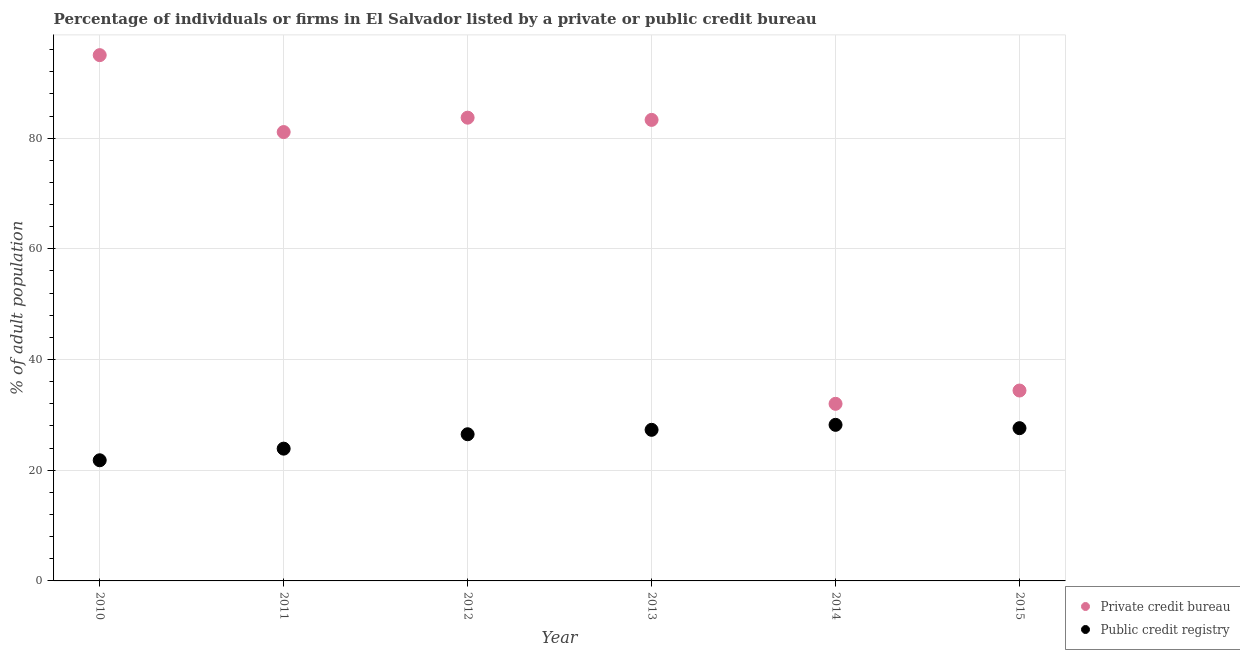How many different coloured dotlines are there?
Give a very brief answer. 2. What is the percentage of firms listed by private credit bureau in 2013?
Offer a terse response. 83.3. Across all years, what is the minimum percentage of firms listed by public credit bureau?
Provide a succinct answer. 21.8. In which year was the percentage of firms listed by private credit bureau maximum?
Your response must be concise. 2010. In which year was the percentage of firms listed by public credit bureau minimum?
Your response must be concise. 2010. What is the total percentage of firms listed by public credit bureau in the graph?
Offer a terse response. 155.3. What is the difference between the percentage of firms listed by public credit bureau in 2010 and that in 2015?
Provide a succinct answer. -5.8. What is the difference between the percentage of firms listed by public credit bureau in 2011 and the percentage of firms listed by private credit bureau in 2013?
Offer a very short reply. -59.4. What is the average percentage of firms listed by public credit bureau per year?
Provide a succinct answer. 25.88. In the year 2013, what is the difference between the percentage of firms listed by private credit bureau and percentage of firms listed by public credit bureau?
Offer a very short reply. 56. What is the ratio of the percentage of firms listed by private credit bureau in 2010 to that in 2013?
Offer a terse response. 1.14. Is the percentage of firms listed by public credit bureau in 2011 less than that in 2012?
Offer a very short reply. Yes. Is the difference between the percentage of firms listed by private credit bureau in 2012 and 2015 greater than the difference between the percentage of firms listed by public credit bureau in 2012 and 2015?
Your answer should be very brief. Yes. What is the difference between the highest and the second highest percentage of firms listed by public credit bureau?
Offer a very short reply. 0.6. What is the difference between the highest and the lowest percentage of firms listed by private credit bureau?
Ensure brevity in your answer.  63. In how many years, is the percentage of firms listed by public credit bureau greater than the average percentage of firms listed by public credit bureau taken over all years?
Your answer should be very brief. 4. Does the percentage of firms listed by private credit bureau monotonically increase over the years?
Provide a succinct answer. No. What is the difference between two consecutive major ticks on the Y-axis?
Your response must be concise. 20. Are the values on the major ticks of Y-axis written in scientific E-notation?
Offer a very short reply. No. Where does the legend appear in the graph?
Offer a very short reply. Bottom right. How many legend labels are there?
Offer a very short reply. 2. How are the legend labels stacked?
Provide a short and direct response. Vertical. What is the title of the graph?
Provide a short and direct response. Percentage of individuals or firms in El Salvador listed by a private or public credit bureau. Does "Food and tobacco" appear as one of the legend labels in the graph?
Keep it short and to the point. No. What is the label or title of the Y-axis?
Offer a very short reply. % of adult population. What is the % of adult population in Private credit bureau in 2010?
Offer a very short reply. 95. What is the % of adult population of Public credit registry in 2010?
Ensure brevity in your answer.  21.8. What is the % of adult population of Private credit bureau in 2011?
Your response must be concise. 81.1. What is the % of adult population of Public credit registry in 2011?
Offer a very short reply. 23.9. What is the % of adult population of Private credit bureau in 2012?
Keep it short and to the point. 83.7. What is the % of adult population of Private credit bureau in 2013?
Offer a very short reply. 83.3. What is the % of adult population of Public credit registry in 2013?
Offer a terse response. 27.3. What is the % of adult population in Private credit bureau in 2014?
Provide a short and direct response. 32. What is the % of adult population in Public credit registry in 2014?
Make the answer very short. 28.2. What is the % of adult population in Private credit bureau in 2015?
Give a very brief answer. 34.4. What is the % of adult population in Public credit registry in 2015?
Your answer should be very brief. 27.6. Across all years, what is the maximum % of adult population in Private credit bureau?
Keep it short and to the point. 95. Across all years, what is the maximum % of adult population in Public credit registry?
Your answer should be compact. 28.2. Across all years, what is the minimum % of adult population in Public credit registry?
Offer a very short reply. 21.8. What is the total % of adult population in Private credit bureau in the graph?
Offer a terse response. 409.5. What is the total % of adult population of Public credit registry in the graph?
Make the answer very short. 155.3. What is the difference between the % of adult population of Private credit bureau in 2010 and that in 2011?
Keep it short and to the point. 13.9. What is the difference between the % of adult population of Public credit registry in 2010 and that in 2011?
Ensure brevity in your answer.  -2.1. What is the difference between the % of adult population in Private credit bureau in 2010 and that in 2012?
Give a very brief answer. 11.3. What is the difference between the % of adult population of Private credit bureau in 2010 and that in 2014?
Ensure brevity in your answer.  63. What is the difference between the % of adult population of Private credit bureau in 2010 and that in 2015?
Your response must be concise. 60.6. What is the difference between the % of adult population of Private credit bureau in 2011 and that in 2012?
Give a very brief answer. -2.6. What is the difference between the % of adult population in Public credit registry in 2011 and that in 2012?
Your answer should be very brief. -2.6. What is the difference between the % of adult population of Private credit bureau in 2011 and that in 2013?
Your response must be concise. -2.2. What is the difference between the % of adult population of Public credit registry in 2011 and that in 2013?
Make the answer very short. -3.4. What is the difference between the % of adult population of Private credit bureau in 2011 and that in 2014?
Keep it short and to the point. 49.1. What is the difference between the % of adult population of Public credit registry in 2011 and that in 2014?
Ensure brevity in your answer.  -4.3. What is the difference between the % of adult population in Private credit bureau in 2011 and that in 2015?
Provide a succinct answer. 46.7. What is the difference between the % of adult population in Public credit registry in 2011 and that in 2015?
Ensure brevity in your answer.  -3.7. What is the difference between the % of adult population in Private credit bureau in 2012 and that in 2013?
Keep it short and to the point. 0.4. What is the difference between the % of adult population of Public credit registry in 2012 and that in 2013?
Keep it short and to the point. -0.8. What is the difference between the % of adult population in Private credit bureau in 2012 and that in 2014?
Provide a short and direct response. 51.7. What is the difference between the % of adult population in Public credit registry in 2012 and that in 2014?
Your answer should be compact. -1.7. What is the difference between the % of adult population of Private credit bureau in 2012 and that in 2015?
Your response must be concise. 49.3. What is the difference between the % of adult population in Private credit bureau in 2013 and that in 2014?
Offer a terse response. 51.3. What is the difference between the % of adult population of Public credit registry in 2013 and that in 2014?
Your response must be concise. -0.9. What is the difference between the % of adult population in Private credit bureau in 2013 and that in 2015?
Ensure brevity in your answer.  48.9. What is the difference between the % of adult population of Public credit registry in 2013 and that in 2015?
Give a very brief answer. -0.3. What is the difference between the % of adult population in Private credit bureau in 2010 and the % of adult population in Public credit registry in 2011?
Keep it short and to the point. 71.1. What is the difference between the % of adult population in Private credit bureau in 2010 and the % of adult population in Public credit registry in 2012?
Provide a short and direct response. 68.5. What is the difference between the % of adult population in Private credit bureau in 2010 and the % of adult population in Public credit registry in 2013?
Your response must be concise. 67.7. What is the difference between the % of adult population in Private credit bureau in 2010 and the % of adult population in Public credit registry in 2014?
Provide a succinct answer. 66.8. What is the difference between the % of adult population of Private credit bureau in 2010 and the % of adult population of Public credit registry in 2015?
Offer a very short reply. 67.4. What is the difference between the % of adult population in Private credit bureau in 2011 and the % of adult population in Public credit registry in 2012?
Ensure brevity in your answer.  54.6. What is the difference between the % of adult population in Private credit bureau in 2011 and the % of adult population in Public credit registry in 2013?
Make the answer very short. 53.8. What is the difference between the % of adult population in Private credit bureau in 2011 and the % of adult population in Public credit registry in 2014?
Keep it short and to the point. 52.9. What is the difference between the % of adult population of Private credit bureau in 2011 and the % of adult population of Public credit registry in 2015?
Your answer should be compact. 53.5. What is the difference between the % of adult population of Private credit bureau in 2012 and the % of adult population of Public credit registry in 2013?
Offer a terse response. 56.4. What is the difference between the % of adult population of Private credit bureau in 2012 and the % of adult population of Public credit registry in 2014?
Your answer should be very brief. 55.5. What is the difference between the % of adult population in Private credit bureau in 2012 and the % of adult population in Public credit registry in 2015?
Your response must be concise. 56.1. What is the difference between the % of adult population in Private credit bureau in 2013 and the % of adult population in Public credit registry in 2014?
Make the answer very short. 55.1. What is the difference between the % of adult population in Private credit bureau in 2013 and the % of adult population in Public credit registry in 2015?
Your response must be concise. 55.7. What is the difference between the % of adult population of Private credit bureau in 2014 and the % of adult population of Public credit registry in 2015?
Offer a terse response. 4.4. What is the average % of adult population of Private credit bureau per year?
Offer a terse response. 68.25. What is the average % of adult population of Public credit registry per year?
Ensure brevity in your answer.  25.88. In the year 2010, what is the difference between the % of adult population in Private credit bureau and % of adult population in Public credit registry?
Ensure brevity in your answer.  73.2. In the year 2011, what is the difference between the % of adult population in Private credit bureau and % of adult population in Public credit registry?
Offer a terse response. 57.2. In the year 2012, what is the difference between the % of adult population of Private credit bureau and % of adult population of Public credit registry?
Ensure brevity in your answer.  57.2. In the year 2015, what is the difference between the % of adult population in Private credit bureau and % of adult population in Public credit registry?
Your answer should be compact. 6.8. What is the ratio of the % of adult population in Private credit bureau in 2010 to that in 2011?
Provide a short and direct response. 1.17. What is the ratio of the % of adult population in Public credit registry in 2010 to that in 2011?
Provide a succinct answer. 0.91. What is the ratio of the % of adult population of Private credit bureau in 2010 to that in 2012?
Your answer should be compact. 1.14. What is the ratio of the % of adult population of Public credit registry in 2010 to that in 2012?
Provide a short and direct response. 0.82. What is the ratio of the % of adult population in Private credit bureau in 2010 to that in 2013?
Your response must be concise. 1.14. What is the ratio of the % of adult population in Public credit registry in 2010 to that in 2013?
Give a very brief answer. 0.8. What is the ratio of the % of adult population of Private credit bureau in 2010 to that in 2014?
Your answer should be very brief. 2.97. What is the ratio of the % of adult population of Public credit registry in 2010 to that in 2014?
Keep it short and to the point. 0.77. What is the ratio of the % of adult population of Private credit bureau in 2010 to that in 2015?
Ensure brevity in your answer.  2.76. What is the ratio of the % of adult population in Public credit registry in 2010 to that in 2015?
Make the answer very short. 0.79. What is the ratio of the % of adult population in Private credit bureau in 2011 to that in 2012?
Give a very brief answer. 0.97. What is the ratio of the % of adult population of Public credit registry in 2011 to that in 2012?
Your answer should be very brief. 0.9. What is the ratio of the % of adult population in Private credit bureau in 2011 to that in 2013?
Your answer should be compact. 0.97. What is the ratio of the % of adult population of Public credit registry in 2011 to that in 2013?
Offer a terse response. 0.88. What is the ratio of the % of adult population of Private credit bureau in 2011 to that in 2014?
Make the answer very short. 2.53. What is the ratio of the % of adult population in Public credit registry in 2011 to that in 2014?
Give a very brief answer. 0.85. What is the ratio of the % of adult population of Private credit bureau in 2011 to that in 2015?
Ensure brevity in your answer.  2.36. What is the ratio of the % of adult population of Public credit registry in 2011 to that in 2015?
Keep it short and to the point. 0.87. What is the ratio of the % of adult population of Private credit bureau in 2012 to that in 2013?
Your answer should be compact. 1. What is the ratio of the % of adult population of Public credit registry in 2012 to that in 2013?
Your response must be concise. 0.97. What is the ratio of the % of adult population in Private credit bureau in 2012 to that in 2014?
Offer a very short reply. 2.62. What is the ratio of the % of adult population in Public credit registry in 2012 to that in 2014?
Give a very brief answer. 0.94. What is the ratio of the % of adult population in Private credit bureau in 2012 to that in 2015?
Ensure brevity in your answer.  2.43. What is the ratio of the % of adult population in Public credit registry in 2012 to that in 2015?
Offer a very short reply. 0.96. What is the ratio of the % of adult population of Private credit bureau in 2013 to that in 2014?
Offer a terse response. 2.6. What is the ratio of the % of adult population of Public credit registry in 2013 to that in 2014?
Keep it short and to the point. 0.97. What is the ratio of the % of adult population in Private credit bureau in 2013 to that in 2015?
Provide a succinct answer. 2.42. What is the ratio of the % of adult population of Private credit bureau in 2014 to that in 2015?
Ensure brevity in your answer.  0.93. What is the ratio of the % of adult population in Public credit registry in 2014 to that in 2015?
Your response must be concise. 1.02. 